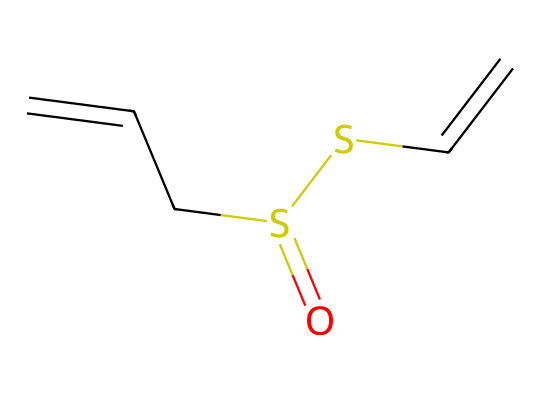What is the total number of carbon atoms in allicin? The SMILES representation indicates there are four carbon atoms present in the structure, which can be counted from the notation (C) in both the side chains and the central part of the molecule.
Answer: four How many double bonds are present in the structure of allicin? The SMILES notation shows two double bonds indicated by the "=" signs, which means there are two double bonds within the molecular structure.
Answer: two What type of functional group does allicin contain? The presence of "S" in the structure indicates that allicin contains a thio-ether functional group (due to the sulfur atoms) and a sulfuryl group due to the presence of the sulfur atom double bonded to oxygen.
Answer: thio-ether What is the molecular formula of allicin? By analyzing the SMILES, we can find out the molecular formula. There are four carbons, six hydrogens, two sulfurs, and one oxygen, which gives the formula C4H8O2S2.
Answer: C4H8O2S2 How many sulfur atoms does allicin have? The SMILES notation includes two occurrences of the "S" character, indicating that there are two sulfur atoms present in the molecular structure.
Answer: two 